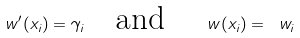<formula> <loc_0><loc_0><loc_500><loc_500>\ w ^ { \prime } ( x _ { i } ) = \gamma _ { i } \quad \text {and} \quad \ w ( x _ { i } ) = \ w _ { i }</formula> 